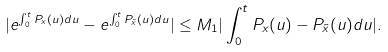<formula> <loc_0><loc_0><loc_500><loc_500>| e ^ { \int _ { 0 } ^ { t } P _ { x } ( u ) d u } - e ^ { \int _ { 0 } ^ { t } P _ { \tilde { x } } ( u ) d u } | \leq M _ { 1 } | \int _ { 0 } ^ { t } P _ { x } ( u ) - P _ { \tilde { x } } ( u ) d u | .</formula> 